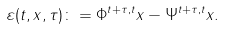Convert formula to latex. <formula><loc_0><loc_0><loc_500><loc_500>\varepsilon ( t , x , \tau ) \colon = \Phi ^ { t + \tau , t } x - \Psi ^ { t + \tau , t } x .</formula> 